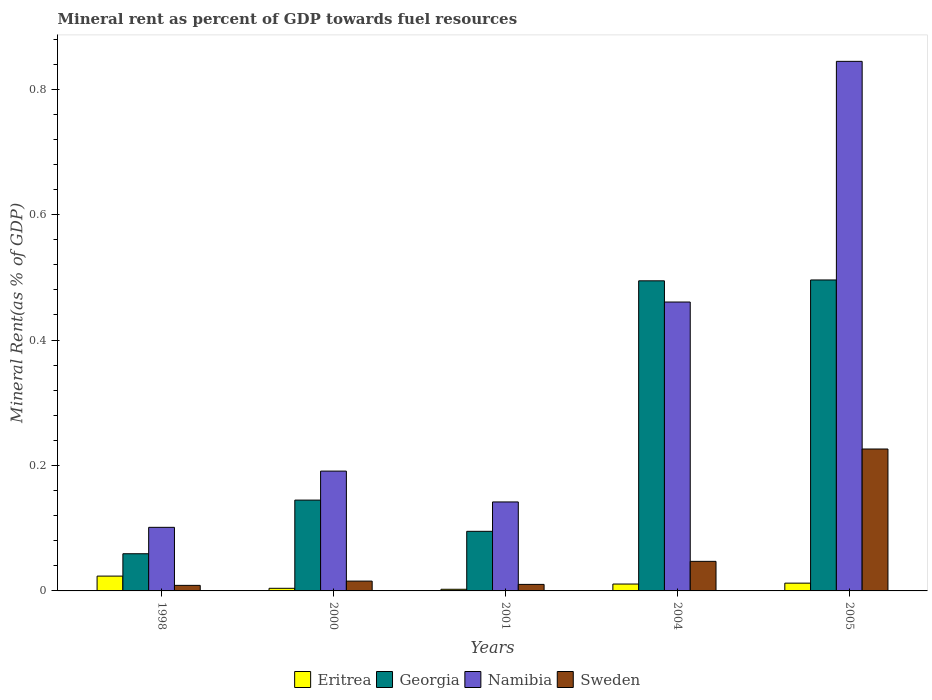How many groups of bars are there?
Provide a succinct answer. 5. Are the number of bars on each tick of the X-axis equal?
Provide a short and direct response. Yes. How many bars are there on the 4th tick from the left?
Keep it short and to the point. 4. How many bars are there on the 5th tick from the right?
Provide a short and direct response. 4. What is the label of the 2nd group of bars from the left?
Make the answer very short. 2000. In how many cases, is the number of bars for a given year not equal to the number of legend labels?
Ensure brevity in your answer.  0. What is the mineral rent in Eritrea in 2001?
Give a very brief answer. 0. Across all years, what is the maximum mineral rent in Eritrea?
Keep it short and to the point. 0.02. Across all years, what is the minimum mineral rent in Georgia?
Your response must be concise. 0.06. What is the total mineral rent in Eritrea in the graph?
Make the answer very short. 0.05. What is the difference between the mineral rent in Namibia in 2001 and that in 2004?
Provide a short and direct response. -0.32. What is the difference between the mineral rent in Georgia in 2005 and the mineral rent in Eritrea in 2004?
Your answer should be compact. 0.48. What is the average mineral rent in Eritrea per year?
Your response must be concise. 0.01. In the year 2004, what is the difference between the mineral rent in Georgia and mineral rent in Sweden?
Your answer should be compact. 0.45. In how many years, is the mineral rent in Georgia greater than 0.7600000000000001 %?
Your response must be concise. 0. What is the ratio of the mineral rent in Georgia in 1998 to that in 2005?
Make the answer very short. 0.12. What is the difference between the highest and the second highest mineral rent in Eritrea?
Make the answer very short. 0.01. What is the difference between the highest and the lowest mineral rent in Eritrea?
Your answer should be very brief. 0.02. In how many years, is the mineral rent in Sweden greater than the average mineral rent in Sweden taken over all years?
Your answer should be very brief. 1. Is the sum of the mineral rent in Eritrea in 2001 and 2004 greater than the maximum mineral rent in Georgia across all years?
Offer a very short reply. No. What does the 4th bar from the right in 2001 represents?
Provide a succinct answer. Eritrea. Is it the case that in every year, the sum of the mineral rent in Sweden and mineral rent in Georgia is greater than the mineral rent in Namibia?
Offer a very short reply. No. Are all the bars in the graph horizontal?
Your response must be concise. No. What is the difference between two consecutive major ticks on the Y-axis?
Make the answer very short. 0.2. Are the values on the major ticks of Y-axis written in scientific E-notation?
Keep it short and to the point. No. Where does the legend appear in the graph?
Offer a very short reply. Bottom center. How many legend labels are there?
Your response must be concise. 4. How are the legend labels stacked?
Provide a succinct answer. Horizontal. What is the title of the graph?
Provide a succinct answer. Mineral rent as percent of GDP towards fuel resources. What is the label or title of the Y-axis?
Offer a terse response. Mineral Rent(as % of GDP). What is the Mineral Rent(as % of GDP) of Eritrea in 1998?
Provide a short and direct response. 0.02. What is the Mineral Rent(as % of GDP) of Georgia in 1998?
Give a very brief answer. 0.06. What is the Mineral Rent(as % of GDP) in Namibia in 1998?
Ensure brevity in your answer.  0.1. What is the Mineral Rent(as % of GDP) of Sweden in 1998?
Offer a terse response. 0.01. What is the Mineral Rent(as % of GDP) in Eritrea in 2000?
Offer a terse response. 0. What is the Mineral Rent(as % of GDP) of Georgia in 2000?
Provide a succinct answer. 0.14. What is the Mineral Rent(as % of GDP) of Namibia in 2000?
Provide a succinct answer. 0.19. What is the Mineral Rent(as % of GDP) of Sweden in 2000?
Your answer should be compact. 0.02. What is the Mineral Rent(as % of GDP) of Eritrea in 2001?
Ensure brevity in your answer.  0. What is the Mineral Rent(as % of GDP) in Georgia in 2001?
Keep it short and to the point. 0.1. What is the Mineral Rent(as % of GDP) in Namibia in 2001?
Your response must be concise. 0.14. What is the Mineral Rent(as % of GDP) of Sweden in 2001?
Your answer should be compact. 0.01. What is the Mineral Rent(as % of GDP) in Eritrea in 2004?
Keep it short and to the point. 0.01. What is the Mineral Rent(as % of GDP) of Georgia in 2004?
Offer a very short reply. 0.49. What is the Mineral Rent(as % of GDP) in Namibia in 2004?
Keep it short and to the point. 0.46. What is the Mineral Rent(as % of GDP) of Sweden in 2004?
Keep it short and to the point. 0.05. What is the Mineral Rent(as % of GDP) of Eritrea in 2005?
Your answer should be very brief. 0.01. What is the Mineral Rent(as % of GDP) in Georgia in 2005?
Provide a succinct answer. 0.5. What is the Mineral Rent(as % of GDP) of Namibia in 2005?
Provide a short and direct response. 0.84. What is the Mineral Rent(as % of GDP) of Sweden in 2005?
Provide a succinct answer. 0.23. Across all years, what is the maximum Mineral Rent(as % of GDP) in Eritrea?
Your response must be concise. 0.02. Across all years, what is the maximum Mineral Rent(as % of GDP) in Georgia?
Your response must be concise. 0.5. Across all years, what is the maximum Mineral Rent(as % of GDP) in Namibia?
Your answer should be very brief. 0.84. Across all years, what is the maximum Mineral Rent(as % of GDP) of Sweden?
Your response must be concise. 0.23. Across all years, what is the minimum Mineral Rent(as % of GDP) in Eritrea?
Offer a very short reply. 0. Across all years, what is the minimum Mineral Rent(as % of GDP) of Georgia?
Provide a short and direct response. 0.06. Across all years, what is the minimum Mineral Rent(as % of GDP) of Namibia?
Your answer should be very brief. 0.1. Across all years, what is the minimum Mineral Rent(as % of GDP) in Sweden?
Keep it short and to the point. 0.01. What is the total Mineral Rent(as % of GDP) of Eritrea in the graph?
Provide a succinct answer. 0.05. What is the total Mineral Rent(as % of GDP) of Georgia in the graph?
Make the answer very short. 1.29. What is the total Mineral Rent(as % of GDP) of Namibia in the graph?
Offer a terse response. 1.74. What is the total Mineral Rent(as % of GDP) in Sweden in the graph?
Provide a succinct answer. 0.31. What is the difference between the Mineral Rent(as % of GDP) in Eritrea in 1998 and that in 2000?
Provide a succinct answer. 0.02. What is the difference between the Mineral Rent(as % of GDP) of Georgia in 1998 and that in 2000?
Make the answer very short. -0.09. What is the difference between the Mineral Rent(as % of GDP) in Namibia in 1998 and that in 2000?
Ensure brevity in your answer.  -0.09. What is the difference between the Mineral Rent(as % of GDP) in Sweden in 1998 and that in 2000?
Your response must be concise. -0.01. What is the difference between the Mineral Rent(as % of GDP) of Eritrea in 1998 and that in 2001?
Provide a succinct answer. 0.02. What is the difference between the Mineral Rent(as % of GDP) in Georgia in 1998 and that in 2001?
Offer a terse response. -0.04. What is the difference between the Mineral Rent(as % of GDP) of Namibia in 1998 and that in 2001?
Make the answer very short. -0.04. What is the difference between the Mineral Rent(as % of GDP) of Sweden in 1998 and that in 2001?
Offer a terse response. -0. What is the difference between the Mineral Rent(as % of GDP) in Eritrea in 1998 and that in 2004?
Give a very brief answer. 0.01. What is the difference between the Mineral Rent(as % of GDP) of Georgia in 1998 and that in 2004?
Your answer should be very brief. -0.44. What is the difference between the Mineral Rent(as % of GDP) in Namibia in 1998 and that in 2004?
Make the answer very short. -0.36. What is the difference between the Mineral Rent(as % of GDP) of Sweden in 1998 and that in 2004?
Ensure brevity in your answer.  -0.04. What is the difference between the Mineral Rent(as % of GDP) of Eritrea in 1998 and that in 2005?
Your answer should be very brief. 0.01. What is the difference between the Mineral Rent(as % of GDP) of Georgia in 1998 and that in 2005?
Your answer should be very brief. -0.44. What is the difference between the Mineral Rent(as % of GDP) in Namibia in 1998 and that in 2005?
Ensure brevity in your answer.  -0.74. What is the difference between the Mineral Rent(as % of GDP) in Sweden in 1998 and that in 2005?
Your response must be concise. -0.22. What is the difference between the Mineral Rent(as % of GDP) of Eritrea in 2000 and that in 2001?
Your answer should be compact. 0. What is the difference between the Mineral Rent(as % of GDP) of Georgia in 2000 and that in 2001?
Keep it short and to the point. 0.05. What is the difference between the Mineral Rent(as % of GDP) of Namibia in 2000 and that in 2001?
Give a very brief answer. 0.05. What is the difference between the Mineral Rent(as % of GDP) of Sweden in 2000 and that in 2001?
Ensure brevity in your answer.  0.01. What is the difference between the Mineral Rent(as % of GDP) of Eritrea in 2000 and that in 2004?
Keep it short and to the point. -0.01. What is the difference between the Mineral Rent(as % of GDP) in Georgia in 2000 and that in 2004?
Make the answer very short. -0.35. What is the difference between the Mineral Rent(as % of GDP) of Namibia in 2000 and that in 2004?
Your answer should be compact. -0.27. What is the difference between the Mineral Rent(as % of GDP) in Sweden in 2000 and that in 2004?
Make the answer very short. -0.03. What is the difference between the Mineral Rent(as % of GDP) of Eritrea in 2000 and that in 2005?
Ensure brevity in your answer.  -0.01. What is the difference between the Mineral Rent(as % of GDP) in Georgia in 2000 and that in 2005?
Offer a very short reply. -0.35. What is the difference between the Mineral Rent(as % of GDP) in Namibia in 2000 and that in 2005?
Offer a terse response. -0.65. What is the difference between the Mineral Rent(as % of GDP) in Sweden in 2000 and that in 2005?
Provide a short and direct response. -0.21. What is the difference between the Mineral Rent(as % of GDP) of Eritrea in 2001 and that in 2004?
Your response must be concise. -0.01. What is the difference between the Mineral Rent(as % of GDP) in Georgia in 2001 and that in 2004?
Give a very brief answer. -0.4. What is the difference between the Mineral Rent(as % of GDP) in Namibia in 2001 and that in 2004?
Keep it short and to the point. -0.32. What is the difference between the Mineral Rent(as % of GDP) in Sweden in 2001 and that in 2004?
Offer a terse response. -0.04. What is the difference between the Mineral Rent(as % of GDP) in Eritrea in 2001 and that in 2005?
Offer a terse response. -0.01. What is the difference between the Mineral Rent(as % of GDP) of Georgia in 2001 and that in 2005?
Your response must be concise. -0.4. What is the difference between the Mineral Rent(as % of GDP) of Namibia in 2001 and that in 2005?
Your response must be concise. -0.7. What is the difference between the Mineral Rent(as % of GDP) in Sweden in 2001 and that in 2005?
Give a very brief answer. -0.22. What is the difference between the Mineral Rent(as % of GDP) in Eritrea in 2004 and that in 2005?
Offer a terse response. -0. What is the difference between the Mineral Rent(as % of GDP) in Georgia in 2004 and that in 2005?
Provide a succinct answer. -0. What is the difference between the Mineral Rent(as % of GDP) in Namibia in 2004 and that in 2005?
Your response must be concise. -0.38. What is the difference between the Mineral Rent(as % of GDP) in Sweden in 2004 and that in 2005?
Offer a terse response. -0.18. What is the difference between the Mineral Rent(as % of GDP) of Eritrea in 1998 and the Mineral Rent(as % of GDP) of Georgia in 2000?
Provide a succinct answer. -0.12. What is the difference between the Mineral Rent(as % of GDP) of Eritrea in 1998 and the Mineral Rent(as % of GDP) of Namibia in 2000?
Your answer should be very brief. -0.17. What is the difference between the Mineral Rent(as % of GDP) of Eritrea in 1998 and the Mineral Rent(as % of GDP) of Sweden in 2000?
Your answer should be very brief. 0.01. What is the difference between the Mineral Rent(as % of GDP) of Georgia in 1998 and the Mineral Rent(as % of GDP) of Namibia in 2000?
Provide a short and direct response. -0.13. What is the difference between the Mineral Rent(as % of GDP) in Georgia in 1998 and the Mineral Rent(as % of GDP) in Sweden in 2000?
Give a very brief answer. 0.04. What is the difference between the Mineral Rent(as % of GDP) in Namibia in 1998 and the Mineral Rent(as % of GDP) in Sweden in 2000?
Give a very brief answer. 0.09. What is the difference between the Mineral Rent(as % of GDP) of Eritrea in 1998 and the Mineral Rent(as % of GDP) of Georgia in 2001?
Provide a succinct answer. -0.07. What is the difference between the Mineral Rent(as % of GDP) in Eritrea in 1998 and the Mineral Rent(as % of GDP) in Namibia in 2001?
Give a very brief answer. -0.12. What is the difference between the Mineral Rent(as % of GDP) of Eritrea in 1998 and the Mineral Rent(as % of GDP) of Sweden in 2001?
Provide a short and direct response. 0.01. What is the difference between the Mineral Rent(as % of GDP) of Georgia in 1998 and the Mineral Rent(as % of GDP) of Namibia in 2001?
Give a very brief answer. -0.08. What is the difference between the Mineral Rent(as % of GDP) of Georgia in 1998 and the Mineral Rent(as % of GDP) of Sweden in 2001?
Offer a terse response. 0.05. What is the difference between the Mineral Rent(as % of GDP) of Namibia in 1998 and the Mineral Rent(as % of GDP) of Sweden in 2001?
Make the answer very short. 0.09. What is the difference between the Mineral Rent(as % of GDP) of Eritrea in 1998 and the Mineral Rent(as % of GDP) of Georgia in 2004?
Offer a very short reply. -0.47. What is the difference between the Mineral Rent(as % of GDP) of Eritrea in 1998 and the Mineral Rent(as % of GDP) of Namibia in 2004?
Make the answer very short. -0.44. What is the difference between the Mineral Rent(as % of GDP) of Eritrea in 1998 and the Mineral Rent(as % of GDP) of Sweden in 2004?
Provide a succinct answer. -0.02. What is the difference between the Mineral Rent(as % of GDP) in Georgia in 1998 and the Mineral Rent(as % of GDP) in Namibia in 2004?
Give a very brief answer. -0.4. What is the difference between the Mineral Rent(as % of GDP) of Georgia in 1998 and the Mineral Rent(as % of GDP) of Sweden in 2004?
Make the answer very short. 0.01. What is the difference between the Mineral Rent(as % of GDP) of Namibia in 1998 and the Mineral Rent(as % of GDP) of Sweden in 2004?
Provide a short and direct response. 0.05. What is the difference between the Mineral Rent(as % of GDP) of Eritrea in 1998 and the Mineral Rent(as % of GDP) of Georgia in 2005?
Your answer should be compact. -0.47. What is the difference between the Mineral Rent(as % of GDP) in Eritrea in 1998 and the Mineral Rent(as % of GDP) in Namibia in 2005?
Give a very brief answer. -0.82. What is the difference between the Mineral Rent(as % of GDP) in Eritrea in 1998 and the Mineral Rent(as % of GDP) in Sweden in 2005?
Your answer should be very brief. -0.2. What is the difference between the Mineral Rent(as % of GDP) of Georgia in 1998 and the Mineral Rent(as % of GDP) of Namibia in 2005?
Your answer should be compact. -0.79. What is the difference between the Mineral Rent(as % of GDP) of Georgia in 1998 and the Mineral Rent(as % of GDP) of Sweden in 2005?
Ensure brevity in your answer.  -0.17. What is the difference between the Mineral Rent(as % of GDP) of Namibia in 1998 and the Mineral Rent(as % of GDP) of Sweden in 2005?
Your answer should be very brief. -0.12. What is the difference between the Mineral Rent(as % of GDP) in Eritrea in 2000 and the Mineral Rent(as % of GDP) in Georgia in 2001?
Provide a short and direct response. -0.09. What is the difference between the Mineral Rent(as % of GDP) in Eritrea in 2000 and the Mineral Rent(as % of GDP) in Namibia in 2001?
Ensure brevity in your answer.  -0.14. What is the difference between the Mineral Rent(as % of GDP) in Eritrea in 2000 and the Mineral Rent(as % of GDP) in Sweden in 2001?
Provide a short and direct response. -0.01. What is the difference between the Mineral Rent(as % of GDP) of Georgia in 2000 and the Mineral Rent(as % of GDP) of Namibia in 2001?
Provide a short and direct response. 0. What is the difference between the Mineral Rent(as % of GDP) of Georgia in 2000 and the Mineral Rent(as % of GDP) of Sweden in 2001?
Offer a terse response. 0.13. What is the difference between the Mineral Rent(as % of GDP) of Namibia in 2000 and the Mineral Rent(as % of GDP) of Sweden in 2001?
Offer a very short reply. 0.18. What is the difference between the Mineral Rent(as % of GDP) of Eritrea in 2000 and the Mineral Rent(as % of GDP) of Georgia in 2004?
Your answer should be very brief. -0.49. What is the difference between the Mineral Rent(as % of GDP) of Eritrea in 2000 and the Mineral Rent(as % of GDP) of Namibia in 2004?
Keep it short and to the point. -0.46. What is the difference between the Mineral Rent(as % of GDP) of Eritrea in 2000 and the Mineral Rent(as % of GDP) of Sweden in 2004?
Your response must be concise. -0.04. What is the difference between the Mineral Rent(as % of GDP) of Georgia in 2000 and the Mineral Rent(as % of GDP) of Namibia in 2004?
Make the answer very short. -0.32. What is the difference between the Mineral Rent(as % of GDP) of Georgia in 2000 and the Mineral Rent(as % of GDP) of Sweden in 2004?
Ensure brevity in your answer.  0.1. What is the difference between the Mineral Rent(as % of GDP) of Namibia in 2000 and the Mineral Rent(as % of GDP) of Sweden in 2004?
Keep it short and to the point. 0.14. What is the difference between the Mineral Rent(as % of GDP) of Eritrea in 2000 and the Mineral Rent(as % of GDP) of Georgia in 2005?
Keep it short and to the point. -0.49. What is the difference between the Mineral Rent(as % of GDP) in Eritrea in 2000 and the Mineral Rent(as % of GDP) in Namibia in 2005?
Offer a terse response. -0.84. What is the difference between the Mineral Rent(as % of GDP) of Eritrea in 2000 and the Mineral Rent(as % of GDP) of Sweden in 2005?
Ensure brevity in your answer.  -0.22. What is the difference between the Mineral Rent(as % of GDP) in Georgia in 2000 and the Mineral Rent(as % of GDP) in Namibia in 2005?
Offer a terse response. -0.7. What is the difference between the Mineral Rent(as % of GDP) in Georgia in 2000 and the Mineral Rent(as % of GDP) in Sweden in 2005?
Your answer should be very brief. -0.08. What is the difference between the Mineral Rent(as % of GDP) in Namibia in 2000 and the Mineral Rent(as % of GDP) in Sweden in 2005?
Your answer should be very brief. -0.04. What is the difference between the Mineral Rent(as % of GDP) in Eritrea in 2001 and the Mineral Rent(as % of GDP) in Georgia in 2004?
Make the answer very short. -0.49. What is the difference between the Mineral Rent(as % of GDP) of Eritrea in 2001 and the Mineral Rent(as % of GDP) of Namibia in 2004?
Your answer should be compact. -0.46. What is the difference between the Mineral Rent(as % of GDP) of Eritrea in 2001 and the Mineral Rent(as % of GDP) of Sweden in 2004?
Provide a succinct answer. -0.04. What is the difference between the Mineral Rent(as % of GDP) in Georgia in 2001 and the Mineral Rent(as % of GDP) in Namibia in 2004?
Offer a terse response. -0.37. What is the difference between the Mineral Rent(as % of GDP) of Georgia in 2001 and the Mineral Rent(as % of GDP) of Sweden in 2004?
Your response must be concise. 0.05. What is the difference between the Mineral Rent(as % of GDP) of Namibia in 2001 and the Mineral Rent(as % of GDP) of Sweden in 2004?
Provide a succinct answer. 0.09. What is the difference between the Mineral Rent(as % of GDP) in Eritrea in 2001 and the Mineral Rent(as % of GDP) in Georgia in 2005?
Offer a terse response. -0.49. What is the difference between the Mineral Rent(as % of GDP) of Eritrea in 2001 and the Mineral Rent(as % of GDP) of Namibia in 2005?
Ensure brevity in your answer.  -0.84. What is the difference between the Mineral Rent(as % of GDP) in Eritrea in 2001 and the Mineral Rent(as % of GDP) in Sweden in 2005?
Your answer should be very brief. -0.22. What is the difference between the Mineral Rent(as % of GDP) in Georgia in 2001 and the Mineral Rent(as % of GDP) in Namibia in 2005?
Keep it short and to the point. -0.75. What is the difference between the Mineral Rent(as % of GDP) of Georgia in 2001 and the Mineral Rent(as % of GDP) of Sweden in 2005?
Provide a succinct answer. -0.13. What is the difference between the Mineral Rent(as % of GDP) of Namibia in 2001 and the Mineral Rent(as % of GDP) of Sweden in 2005?
Provide a short and direct response. -0.08. What is the difference between the Mineral Rent(as % of GDP) of Eritrea in 2004 and the Mineral Rent(as % of GDP) of Georgia in 2005?
Offer a terse response. -0.48. What is the difference between the Mineral Rent(as % of GDP) of Eritrea in 2004 and the Mineral Rent(as % of GDP) of Namibia in 2005?
Keep it short and to the point. -0.83. What is the difference between the Mineral Rent(as % of GDP) in Eritrea in 2004 and the Mineral Rent(as % of GDP) in Sweden in 2005?
Ensure brevity in your answer.  -0.22. What is the difference between the Mineral Rent(as % of GDP) in Georgia in 2004 and the Mineral Rent(as % of GDP) in Namibia in 2005?
Your answer should be compact. -0.35. What is the difference between the Mineral Rent(as % of GDP) of Georgia in 2004 and the Mineral Rent(as % of GDP) of Sweden in 2005?
Offer a very short reply. 0.27. What is the difference between the Mineral Rent(as % of GDP) of Namibia in 2004 and the Mineral Rent(as % of GDP) of Sweden in 2005?
Offer a terse response. 0.23. What is the average Mineral Rent(as % of GDP) in Eritrea per year?
Keep it short and to the point. 0.01. What is the average Mineral Rent(as % of GDP) in Georgia per year?
Provide a short and direct response. 0.26. What is the average Mineral Rent(as % of GDP) of Namibia per year?
Make the answer very short. 0.35. What is the average Mineral Rent(as % of GDP) of Sweden per year?
Provide a succinct answer. 0.06. In the year 1998, what is the difference between the Mineral Rent(as % of GDP) of Eritrea and Mineral Rent(as % of GDP) of Georgia?
Ensure brevity in your answer.  -0.04. In the year 1998, what is the difference between the Mineral Rent(as % of GDP) of Eritrea and Mineral Rent(as % of GDP) of Namibia?
Your answer should be compact. -0.08. In the year 1998, what is the difference between the Mineral Rent(as % of GDP) in Eritrea and Mineral Rent(as % of GDP) in Sweden?
Offer a terse response. 0.01. In the year 1998, what is the difference between the Mineral Rent(as % of GDP) of Georgia and Mineral Rent(as % of GDP) of Namibia?
Your response must be concise. -0.04. In the year 1998, what is the difference between the Mineral Rent(as % of GDP) of Georgia and Mineral Rent(as % of GDP) of Sweden?
Provide a short and direct response. 0.05. In the year 1998, what is the difference between the Mineral Rent(as % of GDP) in Namibia and Mineral Rent(as % of GDP) in Sweden?
Make the answer very short. 0.09. In the year 2000, what is the difference between the Mineral Rent(as % of GDP) of Eritrea and Mineral Rent(as % of GDP) of Georgia?
Make the answer very short. -0.14. In the year 2000, what is the difference between the Mineral Rent(as % of GDP) of Eritrea and Mineral Rent(as % of GDP) of Namibia?
Offer a terse response. -0.19. In the year 2000, what is the difference between the Mineral Rent(as % of GDP) in Eritrea and Mineral Rent(as % of GDP) in Sweden?
Keep it short and to the point. -0.01. In the year 2000, what is the difference between the Mineral Rent(as % of GDP) in Georgia and Mineral Rent(as % of GDP) in Namibia?
Ensure brevity in your answer.  -0.05. In the year 2000, what is the difference between the Mineral Rent(as % of GDP) of Georgia and Mineral Rent(as % of GDP) of Sweden?
Ensure brevity in your answer.  0.13. In the year 2000, what is the difference between the Mineral Rent(as % of GDP) of Namibia and Mineral Rent(as % of GDP) of Sweden?
Offer a very short reply. 0.18. In the year 2001, what is the difference between the Mineral Rent(as % of GDP) in Eritrea and Mineral Rent(as % of GDP) in Georgia?
Give a very brief answer. -0.09. In the year 2001, what is the difference between the Mineral Rent(as % of GDP) of Eritrea and Mineral Rent(as % of GDP) of Namibia?
Your answer should be very brief. -0.14. In the year 2001, what is the difference between the Mineral Rent(as % of GDP) in Eritrea and Mineral Rent(as % of GDP) in Sweden?
Provide a short and direct response. -0.01. In the year 2001, what is the difference between the Mineral Rent(as % of GDP) in Georgia and Mineral Rent(as % of GDP) in Namibia?
Keep it short and to the point. -0.05. In the year 2001, what is the difference between the Mineral Rent(as % of GDP) of Georgia and Mineral Rent(as % of GDP) of Sweden?
Provide a short and direct response. 0.08. In the year 2001, what is the difference between the Mineral Rent(as % of GDP) of Namibia and Mineral Rent(as % of GDP) of Sweden?
Provide a succinct answer. 0.13. In the year 2004, what is the difference between the Mineral Rent(as % of GDP) in Eritrea and Mineral Rent(as % of GDP) in Georgia?
Provide a succinct answer. -0.48. In the year 2004, what is the difference between the Mineral Rent(as % of GDP) in Eritrea and Mineral Rent(as % of GDP) in Namibia?
Your answer should be very brief. -0.45. In the year 2004, what is the difference between the Mineral Rent(as % of GDP) of Eritrea and Mineral Rent(as % of GDP) of Sweden?
Keep it short and to the point. -0.04. In the year 2004, what is the difference between the Mineral Rent(as % of GDP) of Georgia and Mineral Rent(as % of GDP) of Namibia?
Your answer should be very brief. 0.03. In the year 2004, what is the difference between the Mineral Rent(as % of GDP) in Georgia and Mineral Rent(as % of GDP) in Sweden?
Keep it short and to the point. 0.45. In the year 2004, what is the difference between the Mineral Rent(as % of GDP) in Namibia and Mineral Rent(as % of GDP) in Sweden?
Keep it short and to the point. 0.41. In the year 2005, what is the difference between the Mineral Rent(as % of GDP) of Eritrea and Mineral Rent(as % of GDP) of Georgia?
Provide a succinct answer. -0.48. In the year 2005, what is the difference between the Mineral Rent(as % of GDP) in Eritrea and Mineral Rent(as % of GDP) in Namibia?
Give a very brief answer. -0.83. In the year 2005, what is the difference between the Mineral Rent(as % of GDP) of Eritrea and Mineral Rent(as % of GDP) of Sweden?
Make the answer very short. -0.21. In the year 2005, what is the difference between the Mineral Rent(as % of GDP) of Georgia and Mineral Rent(as % of GDP) of Namibia?
Provide a short and direct response. -0.35. In the year 2005, what is the difference between the Mineral Rent(as % of GDP) in Georgia and Mineral Rent(as % of GDP) in Sweden?
Your response must be concise. 0.27. In the year 2005, what is the difference between the Mineral Rent(as % of GDP) of Namibia and Mineral Rent(as % of GDP) of Sweden?
Provide a succinct answer. 0.62. What is the ratio of the Mineral Rent(as % of GDP) of Eritrea in 1998 to that in 2000?
Provide a short and direct response. 5.65. What is the ratio of the Mineral Rent(as % of GDP) in Georgia in 1998 to that in 2000?
Your answer should be compact. 0.41. What is the ratio of the Mineral Rent(as % of GDP) of Namibia in 1998 to that in 2000?
Your response must be concise. 0.53. What is the ratio of the Mineral Rent(as % of GDP) of Sweden in 1998 to that in 2000?
Provide a short and direct response. 0.57. What is the ratio of the Mineral Rent(as % of GDP) in Eritrea in 1998 to that in 2001?
Offer a very short reply. 8.96. What is the ratio of the Mineral Rent(as % of GDP) in Georgia in 1998 to that in 2001?
Provide a short and direct response. 0.62. What is the ratio of the Mineral Rent(as % of GDP) of Namibia in 1998 to that in 2001?
Offer a terse response. 0.71. What is the ratio of the Mineral Rent(as % of GDP) of Sweden in 1998 to that in 2001?
Keep it short and to the point. 0.85. What is the ratio of the Mineral Rent(as % of GDP) in Eritrea in 1998 to that in 2004?
Keep it short and to the point. 2.15. What is the ratio of the Mineral Rent(as % of GDP) in Georgia in 1998 to that in 2004?
Your response must be concise. 0.12. What is the ratio of the Mineral Rent(as % of GDP) in Namibia in 1998 to that in 2004?
Offer a very short reply. 0.22. What is the ratio of the Mineral Rent(as % of GDP) in Sweden in 1998 to that in 2004?
Offer a terse response. 0.19. What is the ratio of the Mineral Rent(as % of GDP) of Eritrea in 1998 to that in 2005?
Provide a succinct answer. 1.91. What is the ratio of the Mineral Rent(as % of GDP) of Georgia in 1998 to that in 2005?
Make the answer very short. 0.12. What is the ratio of the Mineral Rent(as % of GDP) of Namibia in 1998 to that in 2005?
Keep it short and to the point. 0.12. What is the ratio of the Mineral Rent(as % of GDP) of Sweden in 1998 to that in 2005?
Your response must be concise. 0.04. What is the ratio of the Mineral Rent(as % of GDP) of Eritrea in 2000 to that in 2001?
Your response must be concise. 1.59. What is the ratio of the Mineral Rent(as % of GDP) in Georgia in 2000 to that in 2001?
Your answer should be very brief. 1.52. What is the ratio of the Mineral Rent(as % of GDP) in Namibia in 2000 to that in 2001?
Provide a succinct answer. 1.35. What is the ratio of the Mineral Rent(as % of GDP) of Sweden in 2000 to that in 2001?
Your answer should be compact. 1.5. What is the ratio of the Mineral Rent(as % of GDP) in Eritrea in 2000 to that in 2004?
Give a very brief answer. 0.38. What is the ratio of the Mineral Rent(as % of GDP) of Georgia in 2000 to that in 2004?
Give a very brief answer. 0.29. What is the ratio of the Mineral Rent(as % of GDP) in Namibia in 2000 to that in 2004?
Give a very brief answer. 0.41. What is the ratio of the Mineral Rent(as % of GDP) in Sweden in 2000 to that in 2004?
Make the answer very short. 0.33. What is the ratio of the Mineral Rent(as % of GDP) in Eritrea in 2000 to that in 2005?
Provide a succinct answer. 0.34. What is the ratio of the Mineral Rent(as % of GDP) of Georgia in 2000 to that in 2005?
Give a very brief answer. 0.29. What is the ratio of the Mineral Rent(as % of GDP) of Namibia in 2000 to that in 2005?
Provide a short and direct response. 0.23. What is the ratio of the Mineral Rent(as % of GDP) of Sweden in 2000 to that in 2005?
Your answer should be compact. 0.07. What is the ratio of the Mineral Rent(as % of GDP) in Eritrea in 2001 to that in 2004?
Your response must be concise. 0.24. What is the ratio of the Mineral Rent(as % of GDP) of Georgia in 2001 to that in 2004?
Ensure brevity in your answer.  0.19. What is the ratio of the Mineral Rent(as % of GDP) of Namibia in 2001 to that in 2004?
Your answer should be very brief. 0.31. What is the ratio of the Mineral Rent(as % of GDP) in Sweden in 2001 to that in 2004?
Make the answer very short. 0.22. What is the ratio of the Mineral Rent(as % of GDP) in Eritrea in 2001 to that in 2005?
Your answer should be compact. 0.21. What is the ratio of the Mineral Rent(as % of GDP) in Georgia in 2001 to that in 2005?
Give a very brief answer. 0.19. What is the ratio of the Mineral Rent(as % of GDP) in Namibia in 2001 to that in 2005?
Ensure brevity in your answer.  0.17. What is the ratio of the Mineral Rent(as % of GDP) in Sweden in 2001 to that in 2005?
Offer a very short reply. 0.05. What is the ratio of the Mineral Rent(as % of GDP) in Eritrea in 2004 to that in 2005?
Provide a succinct answer. 0.89. What is the ratio of the Mineral Rent(as % of GDP) of Namibia in 2004 to that in 2005?
Give a very brief answer. 0.55. What is the ratio of the Mineral Rent(as % of GDP) of Sweden in 2004 to that in 2005?
Keep it short and to the point. 0.21. What is the difference between the highest and the second highest Mineral Rent(as % of GDP) of Eritrea?
Offer a terse response. 0.01. What is the difference between the highest and the second highest Mineral Rent(as % of GDP) of Georgia?
Your answer should be compact. 0. What is the difference between the highest and the second highest Mineral Rent(as % of GDP) of Namibia?
Give a very brief answer. 0.38. What is the difference between the highest and the second highest Mineral Rent(as % of GDP) of Sweden?
Offer a very short reply. 0.18. What is the difference between the highest and the lowest Mineral Rent(as % of GDP) in Eritrea?
Your response must be concise. 0.02. What is the difference between the highest and the lowest Mineral Rent(as % of GDP) of Georgia?
Keep it short and to the point. 0.44. What is the difference between the highest and the lowest Mineral Rent(as % of GDP) of Namibia?
Your answer should be very brief. 0.74. What is the difference between the highest and the lowest Mineral Rent(as % of GDP) in Sweden?
Provide a succinct answer. 0.22. 